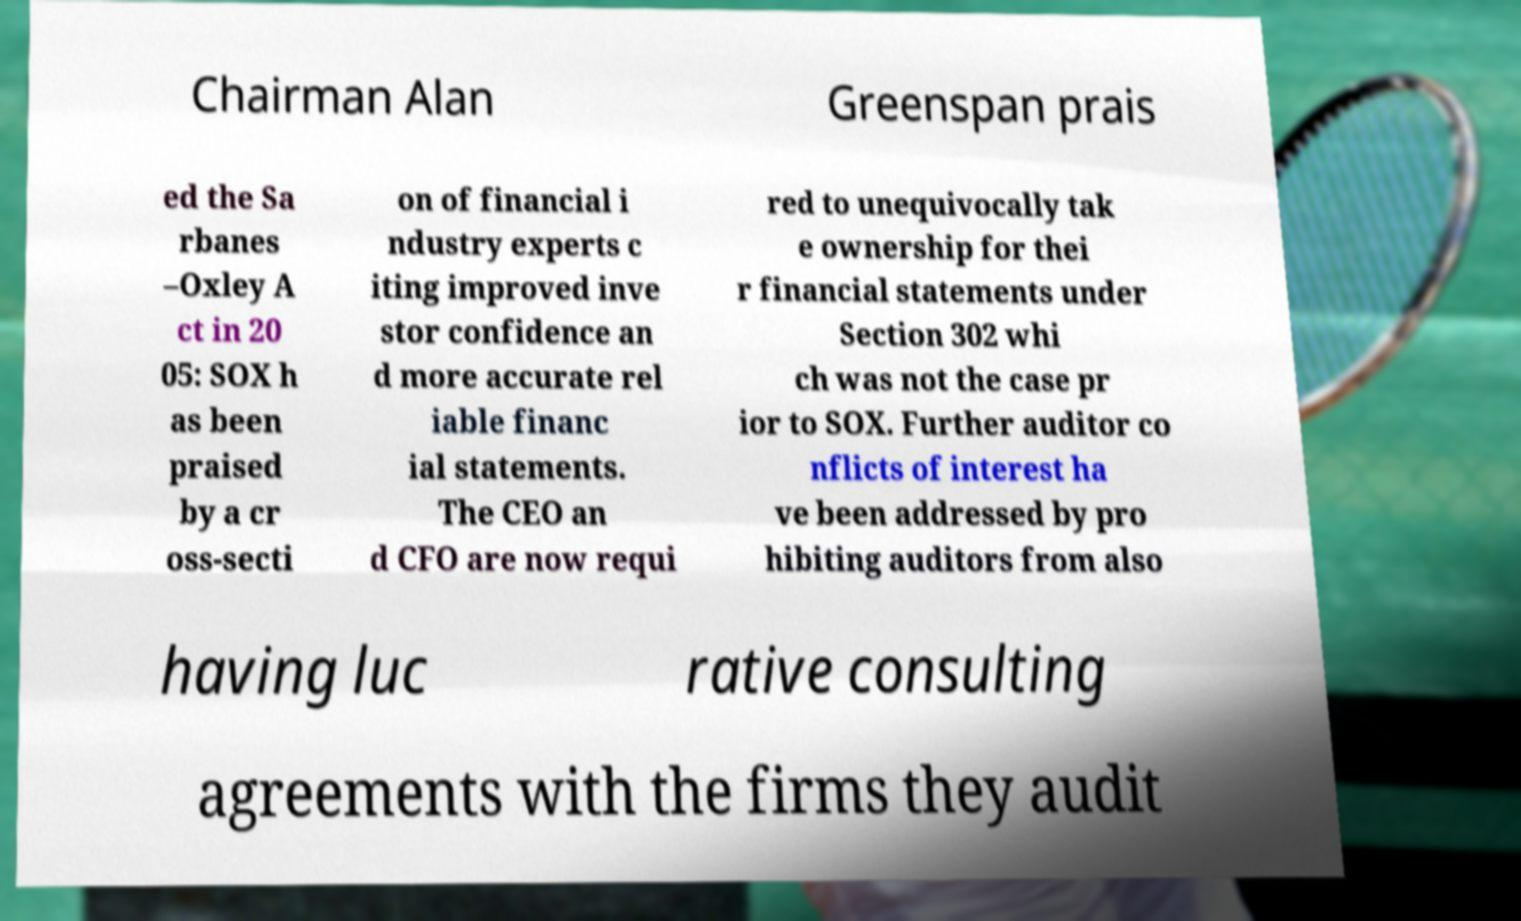Could you assist in decoding the text presented in this image and type it out clearly? Chairman Alan Greenspan prais ed the Sa rbanes –Oxley A ct in 20 05: SOX h as been praised by a cr oss-secti on of financial i ndustry experts c iting improved inve stor confidence an d more accurate rel iable financ ial statements. The CEO an d CFO are now requi red to unequivocally tak e ownership for thei r financial statements under Section 302 whi ch was not the case pr ior to SOX. Further auditor co nflicts of interest ha ve been addressed by pro hibiting auditors from also having luc rative consulting agreements with the firms they audit 